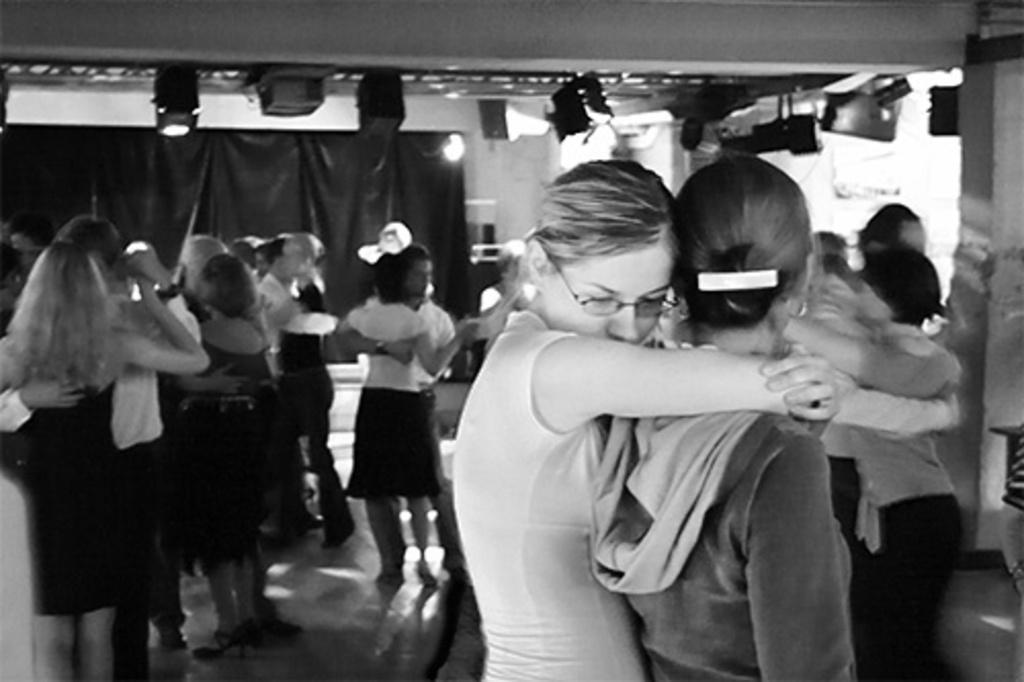Can you describe this image briefly? As we can see in the image there are few people here and there, cloth, lights and a white color wall. 